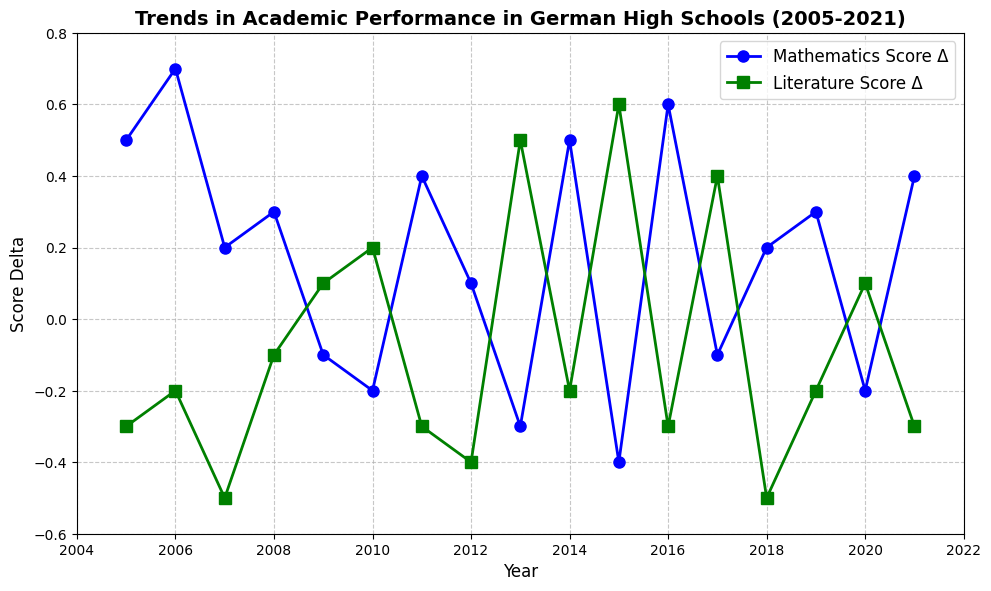What is the general trend in mathematics scores from 2005 to 2021? By looking at the figure, we can see that the mathematics score delta varies over the years. Although there are some dips (e.g., 2009, 2010, 2013, and 2015), overall, the trend is slightly positive, as there are more years with positive deltas than negative ones.
Answer: Slightly positive How did the literature scores change between 2005 and 2013? From the figure, we can observe that the literature score delta is mostly negative from 2005 until 2012 but becomes positive in 2013. Therefore, the literature scores first declined and then improved by 2013.
Answer: Declined, then improved Which year had the highest positive delta in literature scores? The highest positive delta in literature scores can be identified by looking for the highest point on the green line. The year 2015 shows the largest positive delta in literature scores (0.6).
Answer: 2015 Did any years show an increase in mathematics scores but a decrease in literature scores simultaneously? To answer this, we need to find years where the blue line is above zero (positive delta) and the green line is below zero (negative delta). The years 2005, 2006, 2008, 2011, 2012, 2014, 2016, 2018, and 2021 show these characteristics.
Answer: 2005, 2006, 2008, 2011, 2012, 2014, 2016, 2018, 2021 What's the average mathematics delta for the years when the literature delta was positive? To calculate this, we first identify the years where the literature delta is positive (2009, 2010, 2013, 2015, 2017, and 2020). Then, we sum the corresponding mathematics deltas: -0.1 (2009) + (-0.2) (2010) + (-0.3) (2013) + (-0.4) (2015) + (-0.1) (2017) + (-0.2) (2020) = -1.3. Finally, we divide by the number of years (6), resulting in an average delta of -0.217.
Answer: -0.217 During which consecutive years did mathematics scores see the most consistent increase? Observing the blue line for consecutive positive deltas, from 2005 to 2006, the scores increased consistently for two years (0.5 to 0.7). Another consistent increase is from 2015 to 2016 (0.6), suggesting that scores increased consistently in these periods.
Answer: 2005-2006 and 2015-2016 Is there any relation between the patterns of changes in mathematics and literature scores? By analyzing the patterns, one can see that in many years when mathematics scores increased, literature scores decreased (e.g., 2005, 2006, 2008, 2011, etc.), indicating an inverse relationship in those years. This suggests some form of correlation where improvements in one subject might coincide with a decline in the other.
Answer: Inverse relationship Which year had the lowest mathematics score delta, and what was the literature score delta for that year? The lowest mathematics score delta can be found by locating the lowest point on the blue line. In 2015, the mathematics delta was -0.4, and the literature score delta for that year was 0.6.
Answer: 2015, 0.6 